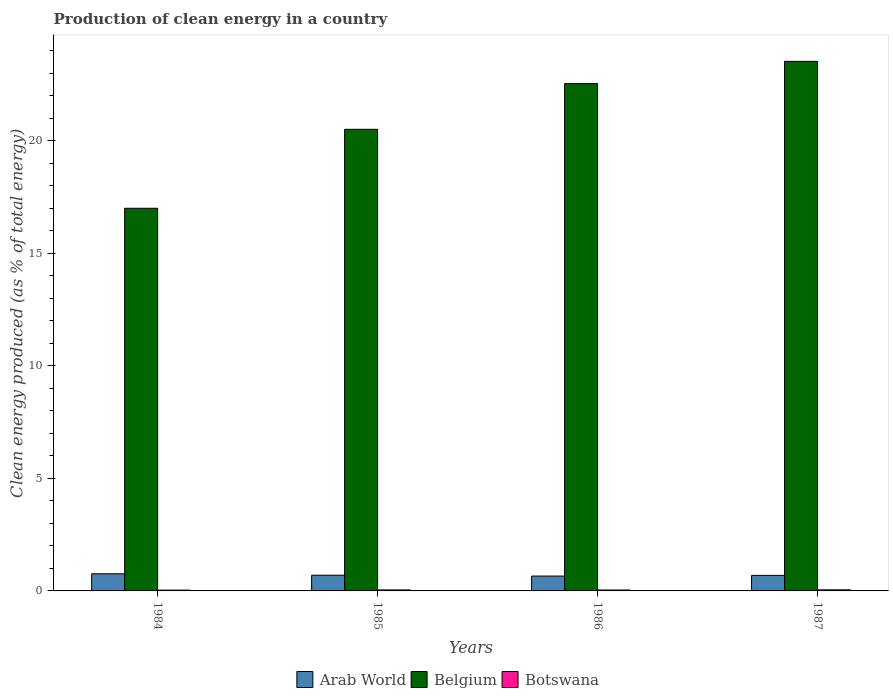How many groups of bars are there?
Offer a terse response. 4. Are the number of bars on each tick of the X-axis equal?
Give a very brief answer. Yes. How many bars are there on the 1st tick from the left?
Offer a terse response. 3. How many bars are there on the 1st tick from the right?
Make the answer very short. 3. In how many cases, is the number of bars for a given year not equal to the number of legend labels?
Offer a terse response. 0. What is the percentage of clean energy produced in Arab World in 1984?
Your response must be concise. 0.76. Across all years, what is the maximum percentage of clean energy produced in Botswana?
Offer a very short reply. 0.05. Across all years, what is the minimum percentage of clean energy produced in Botswana?
Ensure brevity in your answer.  0.04. In which year was the percentage of clean energy produced in Belgium minimum?
Ensure brevity in your answer.  1984. What is the total percentage of clean energy produced in Botswana in the graph?
Provide a succinct answer. 0.17. What is the difference between the percentage of clean energy produced in Botswana in 1985 and that in 1987?
Provide a short and direct response. -0. What is the difference between the percentage of clean energy produced in Botswana in 1987 and the percentage of clean energy produced in Arab World in 1985?
Make the answer very short. -0.65. What is the average percentage of clean energy produced in Arab World per year?
Your response must be concise. 0.7. In the year 1985, what is the difference between the percentage of clean energy produced in Arab World and percentage of clean energy produced in Belgium?
Your response must be concise. -19.8. What is the ratio of the percentage of clean energy produced in Botswana in 1984 to that in 1985?
Make the answer very short. 0.79. What is the difference between the highest and the second highest percentage of clean energy produced in Arab World?
Make the answer very short. 0.06. What is the difference between the highest and the lowest percentage of clean energy produced in Botswana?
Provide a succinct answer. 0.01. In how many years, is the percentage of clean energy produced in Arab World greater than the average percentage of clean energy produced in Arab World taken over all years?
Offer a very short reply. 1. What does the 3rd bar from the left in 1984 represents?
Keep it short and to the point. Botswana. What does the 2nd bar from the right in 1985 represents?
Your response must be concise. Belgium. How many years are there in the graph?
Provide a short and direct response. 4. What is the difference between two consecutive major ticks on the Y-axis?
Provide a succinct answer. 5. How are the legend labels stacked?
Ensure brevity in your answer.  Horizontal. What is the title of the graph?
Keep it short and to the point. Production of clean energy in a country. What is the label or title of the Y-axis?
Your answer should be compact. Clean energy produced (as % of total energy). What is the Clean energy produced (as % of total energy) of Arab World in 1984?
Provide a succinct answer. 0.76. What is the Clean energy produced (as % of total energy) of Belgium in 1984?
Ensure brevity in your answer.  16.99. What is the Clean energy produced (as % of total energy) in Botswana in 1984?
Offer a very short reply. 0.04. What is the Clean energy produced (as % of total energy) in Arab World in 1985?
Ensure brevity in your answer.  0.7. What is the Clean energy produced (as % of total energy) of Belgium in 1985?
Keep it short and to the point. 20.5. What is the Clean energy produced (as % of total energy) of Botswana in 1985?
Keep it short and to the point. 0.04. What is the Clean energy produced (as % of total energy) of Arab World in 1986?
Your answer should be very brief. 0.66. What is the Clean energy produced (as % of total energy) of Belgium in 1986?
Give a very brief answer. 22.53. What is the Clean energy produced (as % of total energy) of Botswana in 1986?
Make the answer very short. 0.04. What is the Clean energy produced (as % of total energy) in Arab World in 1987?
Ensure brevity in your answer.  0.69. What is the Clean energy produced (as % of total energy) of Belgium in 1987?
Your answer should be very brief. 23.52. What is the Clean energy produced (as % of total energy) of Botswana in 1987?
Give a very brief answer. 0.05. Across all years, what is the maximum Clean energy produced (as % of total energy) of Arab World?
Your answer should be very brief. 0.76. Across all years, what is the maximum Clean energy produced (as % of total energy) of Belgium?
Your response must be concise. 23.52. Across all years, what is the maximum Clean energy produced (as % of total energy) of Botswana?
Give a very brief answer. 0.05. Across all years, what is the minimum Clean energy produced (as % of total energy) of Arab World?
Provide a succinct answer. 0.66. Across all years, what is the minimum Clean energy produced (as % of total energy) in Belgium?
Your answer should be very brief. 16.99. Across all years, what is the minimum Clean energy produced (as % of total energy) in Botswana?
Ensure brevity in your answer.  0.04. What is the total Clean energy produced (as % of total energy) of Arab World in the graph?
Your response must be concise. 2.81. What is the total Clean energy produced (as % of total energy) in Belgium in the graph?
Offer a terse response. 83.54. What is the total Clean energy produced (as % of total energy) of Botswana in the graph?
Ensure brevity in your answer.  0.17. What is the difference between the Clean energy produced (as % of total energy) in Arab World in 1984 and that in 1985?
Your answer should be very brief. 0.06. What is the difference between the Clean energy produced (as % of total energy) of Belgium in 1984 and that in 1985?
Give a very brief answer. -3.51. What is the difference between the Clean energy produced (as % of total energy) in Botswana in 1984 and that in 1985?
Provide a short and direct response. -0.01. What is the difference between the Clean energy produced (as % of total energy) in Arab World in 1984 and that in 1986?
Give a very brief answer. 0.1. What is the difference between the Clean energy produced (as % of total energy) in Belgium in 1984 and that in 1986?
Keep it short and to the point. -5.54. What is the difference between the Clean energy produced (as % of total energy) in Botswana in 1984 and that in 1986?
Give a very brief answer. -0.01. What is the difference between the Clean energy produced (as % of total energy) of Arab World in 1984 and that in 1987?
Your response must be concise. 0.07. What is the difference between the Clean energy produced (as % of total energy) in Belgium in 1984 and that in 1987?
Give a very brief answer. -6.52. What is the difference between the Clean energy produced (as % of total energy) of Botswana in 1984 and that in 1987?
Keep it short and to the point. -0.01. What is the difference between the Clean energy produced (as % of total energy) of Arab World in 1985 and that in 1986?
Make the answer very short. 0.04. What is the difference between the Clean energy produced (as % of total energy) of Belgium in 1985 and that in 1986?
Your answer should be very brief. -2.03. What is the difference between the Clean energy produced (as % of total energy) in Botswana in 1985 and that in 1986?
Your answer should be compact. 0. What is the difference between the Clean energy produced (as % of total energy) of Arab World in 1985 and that in 1987?
Make the answer very short. 0.01. What is the difference between the Clean energy produced (as % of total energy) of Belgium in 1985 and that in 1987?
Provide a succinct answer. -3.02. What is the difference between the Clean energy produced (as % of total energy) in Botswana in 1985 and that in 1987?
Give a very brief answer. -0. What is the difference between the Clean energy produced (as % of total energy) in Arab World in 1986 and that in 1987?
Offer a very short reply. -0.03. What is the difference between the Clean energy produced (as % of total energy) of Belgium in 1986 and that in 1987?
Offer a very short reply. -0.99. What is the difference between the Clean energy produced (as % of total energy) in Botswana in 1986 and that in 1987?
Provide a short and direct response. -0.01. What is the difference between the Clean energy produced (as % of total energy) in Arab World in 1984 and the Clean energy produced (as % of total energy) in Belgium in 1985?
Your answer should be very brief. -19.74. What is the difference between the Clean energy produced (as % of total energy) in Arab World in 1984 and the Clean energy produced (as % of total energy) in Botswana in 1985?
Ensure brevity in your answer.  0.72. What is the difference between the Clean energy produced (as % of total energy) of Belgium in 1984 and the Clean energy produced (as % of total energy) of Botswana in 1985?
Provide a succinct answer. 16.95. What is the difference between the Clean energy produced (as % of total energy) in Arab World in 1984 and the Clean energy produced (as % of total energy) in Belgium in 1986?
Your response must be concise. -21.77. What is the difference between the Clean energy produced (as % of total energy) of Arab World in 1984 and the Clean energy produced (as % of total energy) of Botswana in 1986?
Your response must be concise. 0.72. What is the difference between the Clean energy produced (as % of total energy) of Belgium in 1984 and the Clean energy produced (as % of total energy) of Botswana in 1986?
Offer a terse response. 16.95. What is the difference between the Clean energy produced (as % of total energy) in Arab World in 1984 and the Clean energy produced (as % of total energy) in Belgium in 1987?
Provide a short and direct response. -22.76. What is the difference between the Clean energy produced (as % of total energy) of Arab World in 1984 and the Clean energy produced (as % of total energy) of Botswana in 1987?
Your answer should be very brief. 0.71. What is the difference between the Clean energy produced (as % of total energy) of Belgium in 1984 and the Clean energy produced (as % of total energy) of Botswana in 1987?
Your answer should be very brief. 16.95. What is the difference between the Clean energy produced (as % of total energy) in Arab World in 1985 and the Clean energy produced (as % of total energy) in Belgium in 1986?
Ensure brevity in your answer.  -21.83. What is the difference between the Clean energy produced (as % of total energy) in Arab World in 1985 and the Clean energy produced (as % of total energy) in Botswana in 1986?
Keep it short and to the point. 0.66. What is the difference between the Clean energy produced (as % of total energy) of Belgium in 1985 and the Clean energy produced (as % of total energy) of Botswana in 1986?
Offer a very short reply. 20.46. What is the difference between the Clean energy produced (as % of total energy) in Arab World in 1985 and the Clean energy produced (as % of total energy) in Belgium in 1987?
Your response must be concise. -22.82. What is the difference between the Clean energy produced (as % of total energy) of Arab World in 1985 and the Clean energy produced (as % of total energy) of Botswana in 1987?
Ensure brevity in your answer.  0.65. What is the difference between the Clean energy produced (as % of total energy) of Belgium in 1985 and the Clean energy produced (as % of total energy) of Botswana in 1987?
Provide a succinct answer. 20.45. What is the difference between the Clean energy produced (as % of total energy) in Arab World in 1986 and the Clean energy produced (as % of total energy) in Belgium in 1987?
Make the answer very short. -22.86. What is the difference between the Clean energy produced (as % of total energy) of Arab World in 1986 and the Clean energy produced (as % of total energy) of Botswana in 1987?
Your answer should be compact. 0.61. What is the difference between the Clean energy produced (as % of total energy) of Belgium in 1986 and the Clean energy produced (as % of total energy) of Botswana in 1987?
Make the answer very short. 22.48. What is the average Clean energy produced (as % of total energy) of Arab World per year?
Provide a succinct answer. 0.7. What is the average Clean energy produced (as % of total energy) in Belgium per year?
Offer a terse response. 20.89. What is the average Clean energy produced (as % of total energy) of Botswana per year?
Your response must be concise. 0.04. In the year 1984, what is the difference between the Clean energy produced (as % of total energy) in Arab World and Clean energy produced (as % of total energy) in Belgium?
Provide a short and direct response. -16.23. In the year 1984, what is the difference between the Clean energy produced (as % of total energy) of Arab World and Clean energy produced (as % of total energy) of Botswana?
Provide a succinct answer. 0.73. In the year 1984, what is the difference between the Clean energy produced (as % of total energy) in Belgium and Clean energy produced (as % of total energy) in Botswana?
Provide a short and direct response. 16.96. In the year 1985, what is the difference between the Clean energy produced (as % of total energy) in Arab World and Clean energy produced (as % of total energy) in Belgium?
Provide a short and direct response. -19.8. In the year 1985, what is the difference between the Clean energy produced (as % of total energy) in Arab World and Clean energy produced (as % of total energy) in Botswana?
Your answer should be very brief. 0.65. In the year 1985, what is the difference between the Clean energy produced (as % of total energy) in Belgium and Clean energy produced (as % of total energy) in Botswana?
Offer a terse response. 20.46. In the year 1986, what is the difference between the Clean energy produced (as % of total energy) of Arab World and Clean energy produced (as % of total energy) of Belgium?
Offer a very short reply. -21.87. In the year 1986, what is the difference between the Clean energy produced (as % of total energy) in Arab World and Clean energy produced (as % of total energy) in Botswana?
Provide a short and direct response. 0.62. In the year 1986, what is the difference between the Clean energy produced (as % of total energy) of Belgium and Clean energy produced (as % of total energy) of Botswana?
Give a very brief answer. 22.49. In the year 1987, what is the difference between the Clean energy produced (as % of total energy) of Arab World and Clean energy produced (as % of total energy) of Belgium?
Your response must be concise. -22.83. In the year 1987, what is the difference between the Clean energy produced (as % of total energy) in Arab World and Clean energy produced (as % of total energy) in Botswana?
Offer a very short reply. 0.64. In the year 1987, what is the difference between the Clean energy produced (as % of total energy) in Belgium and Clean energy produced (as % of total energy) in Botswana?
Keep it short and to the point. 23.47. What is the ratio of the Clean energy produced (as % of total energy) in Belgium in 1984 to that in 1985?
Offer a very short reply. 0.83. What is the ratio of the Clean energy produced (as % of total energy) in Botswana in 1984 to that in 1985?
Offer a very short reply. 0.79. What is the ratio of the Clean energy produced (as % of total energy) in Arab World in 1984 to that in 1986?
Your answer should be compact. 1.15. What is the ratio of the Clean energy produced (as % of total energy) in Belgium in 1984 to that in 1986?
Keep it short and to the point. 0.75. What is the ratio of the Clean energy produced (as % of total energy) in Botswana in 1984 to that in 1986?
Offer a terse response. 0.87. What is the ratio of the Clean energy produced (as % of total energy) in Arab World in 1984 to that in 1987?
Offer a terse response. 1.1. What is the ratio of the Clean energy produced (as % of total energy) in Belgium in 1984 to that in 1987?
Make the answer very short. 0.72. What is the ratio of the Clean energy produced (as % of total energy) of Botswana in 1984 to that in 1987?
Provide a short and direct response. 0.73. What is the ratio of the Clean energy produced (as % of total energy) in Arab World in 1985 to that in 1986?
Ensure brevity in your answer.  1.06. What is the ratio of the Clean energy produced (as % of total energy) of Belgium in 1985 to that in 1986?
Make the answer very short. 0.91. What is the ratio of the Clean energy produced (as % of total energy) in Botswana in 1985 to that in 1986?
Ensure brevity in your answer.  1.1. What is the ratio of the Clean energy produced (as % of total energy) in Arab World in 1985 to that in 1987?
Offer a very short reply. 1.01. What is the ratio of the Clean energy produced (as % of total energy) of Belgium in 1985 to that in 1987?
Provide a short and direct response. 0.87. What is the ratio of the Clean energy produced (as % of total energy) in Botswana in 1985 to that in 1987?
Give a very brief answer. 0.92. What is the ratio of the Clean energy produced (as % of total energy) of Arab World in 1986 to that in 1987?
Provide a short and direct response. 0.96. What is the ratio of the Clean energy produced (as % of total energy) of Belgium in 1986 to that in 1987?
Give a very brief answer. 0.96. What is the ratio of the Clean energy produced (as % of total energy) in Botswana in 1986 to that in 1987?
Your answer should be compact. 0.84. What is the difference between the highest and the second highest Clean energy produced (as % of total energy) of Arab World?
Keep it short and to the point. 0.06. What is the difference between the highest and the second highest Clean energy produced (as % of total energy) in Belgium?
Provide a short and direct response. 0.99. What is the difference between the highest and the second highest Clean energy produced (as % of total energy) of Botswana?
Make the answer very short. 0. What is the difference between the highest and the lowest Clean energy produced (as % of total energy) of Arab World?
Ensure brevity in your answer.  0.1. What is the difference between the highest and the lowest Clean energy produced (as % of total energy) of Belgium?
Make the answer very short. 6.52. What is the difference between the highest and the lowest Clean energy produced (as % of total energy) of Botswana?
Keep it short and to the point. 0.01. 